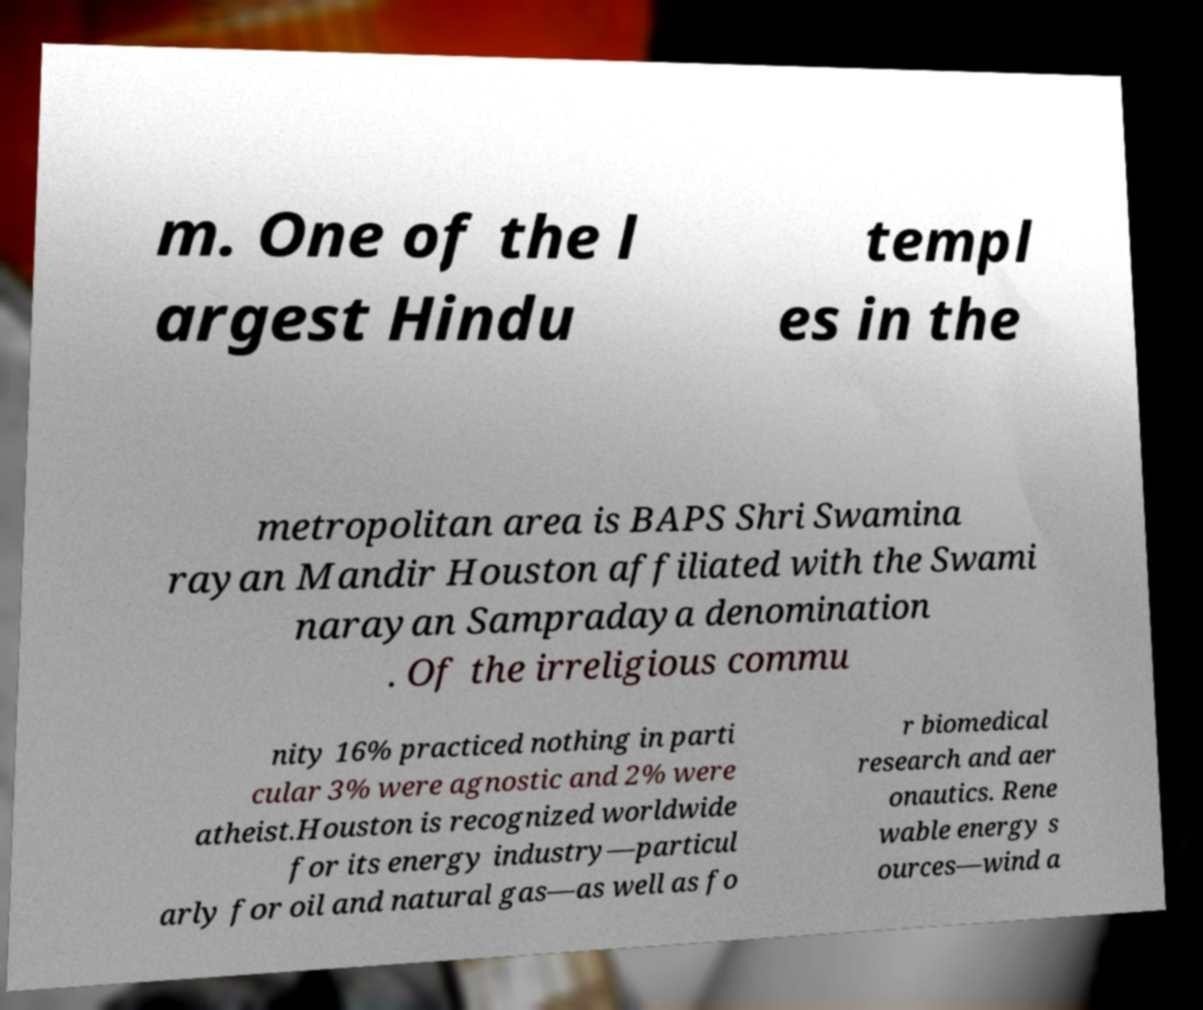Can you read and provide the text displayed in the image?This photo seems to have some interesting text. Can you extract and type it out for me? m. One of the l argest Hindu templ es in the metropolitan area is BAPS Shri Swamina rayan Mandir Houston affiliated with the Swami narayan Sampradaya denomination . Of the irreligious commu nity 16% practiced nothing in parti cular 3% were agnostic and 2% were atheist.Houston is recognized worldwide for its energy industry—particul arly for oil and natural gas—as well as fo r biomedical research and aer onautics. Rene wable energy s ources—wind a 